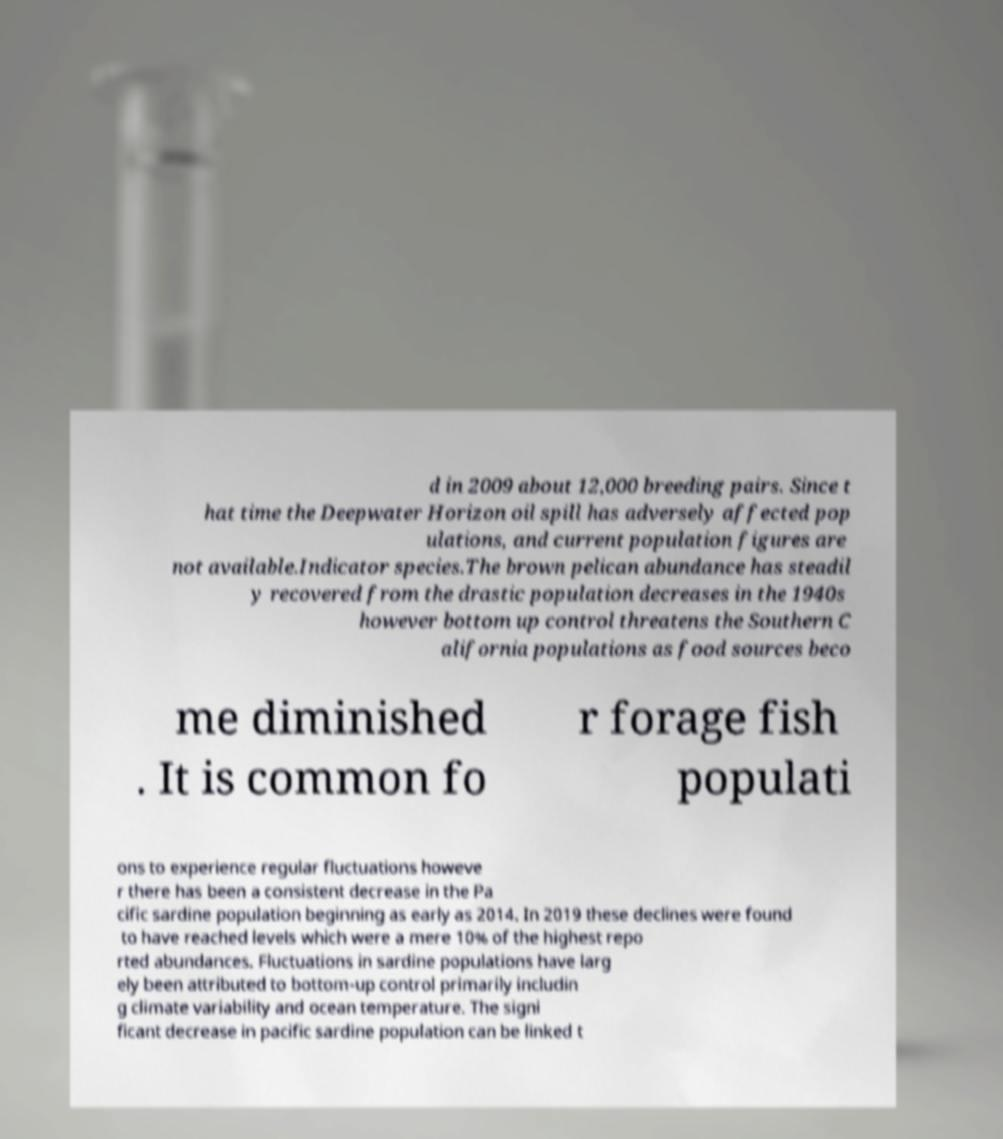Please identify and transcribe the text found in this image. d in 2009 about 12,000 breeding pairs. Since t hat time the Deepwater Horizon oil spill has adversely affected pop ulations, and current population figures are not available.Indicator species.The brown pelican abundance has steadil y recovered from the drastic population decreases in the 1940s however bottom up control threatens the Southern C alifornia populations as food sources beco me diminished . It is common fo r forage fish populati ons to experience regular fluctuations howeve r there has been a consistent decrease in the Pa cific sardine population beginning as early as 2014. In 2019 these declines were found to have reached levels which were a mere 10% of the highest repo rted abundances. Fluctuations in sardine populations have larg ely been attributed to bottom-up control primarily includin g climate variability and ocean temperature. The signi ficant decrease in pacific sardine population can be linked t 